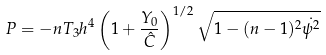Convert formula to latex. <formula><loc_0><loc_0><loc_500><loc_500>P = - n T _ { 3 } h ^ { 4 } \left ( 1 + \frac { Y _ { 0 } } { \hat { C } } \right ) ^ { 1 / 2 } \sqrt { 1 - ( n - 1 ) ^ { 2 } \dot { \psi ^ { 2 } } }</formula> 